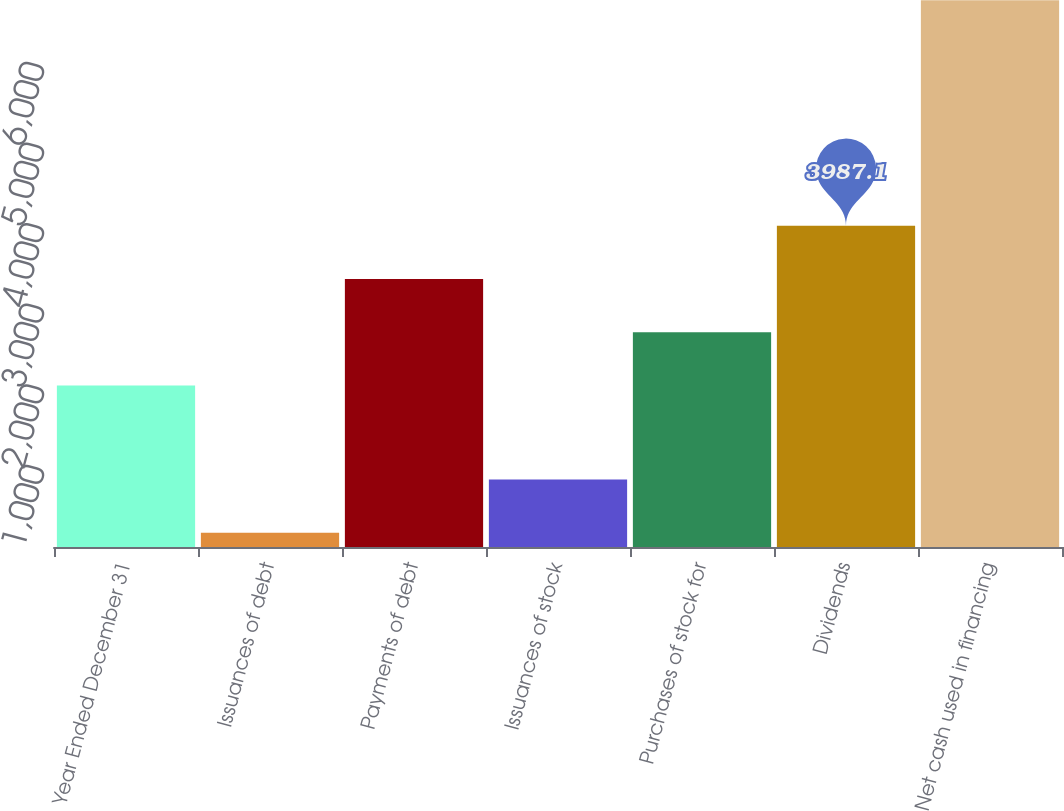Convert chart. <chart><loc_0><loc_0><loc_500><loc_500><bar_chart><fcel>Year Ended December 31<fcel>Issuances of debt<fcel>Payments of debt<fcel>Issuances of stock<fcel>Purchases of stock for<fcel>Dividends<fcel>Net cash used in financing<nl><fcel>2005<fcel>178<fcel>3326.4<fcel>838.7<fcel>2665.7<fcel>3987.1<fcel>6785<nl></chart> 